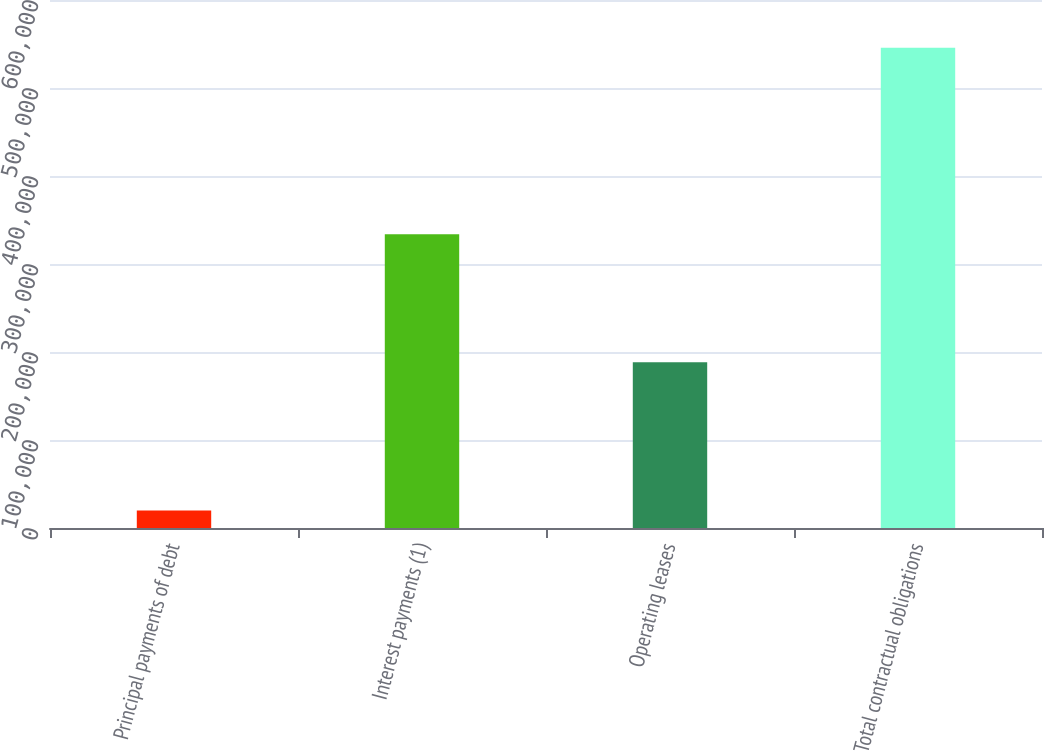<chart> <loc_0><loc_0><loc_500><loc_500><bar_chart><fcel>Principal payments of debt<fcel>Interest payments (1)<fcel>Operating leases<fcel>Total contractual obligations<nl><fcel>20000<fcel>333741<fcel>188382<fcel>545842<nl></chart> 